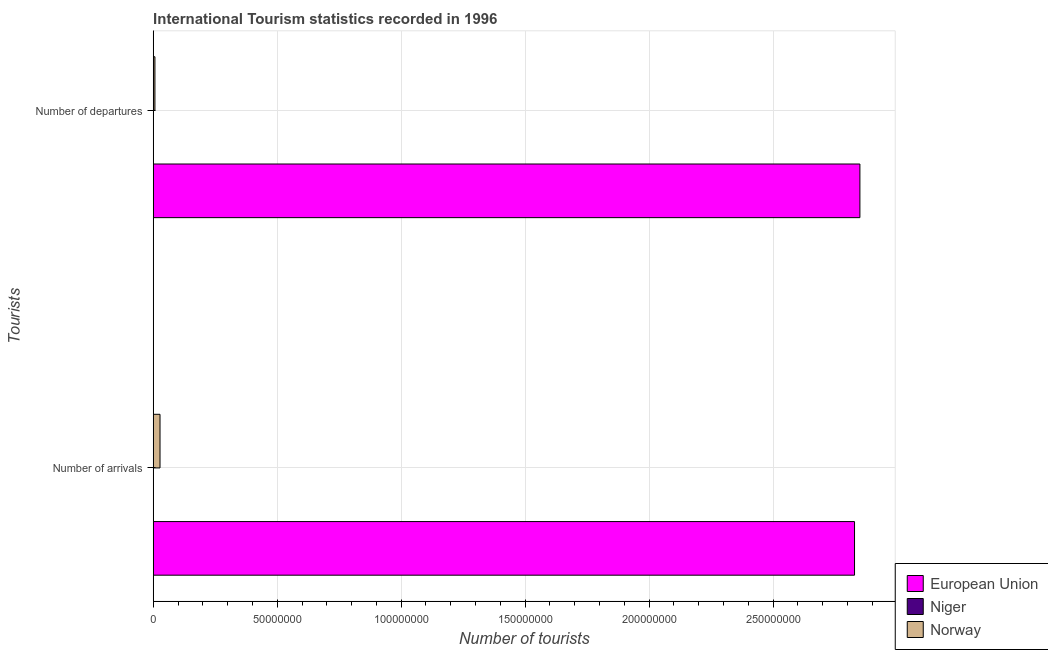How many different coloured bars are there?
Keep it short and to the point. 3. How many groups of bars are there?
Provide a short and direct response. 2. How many bars are there on the 1st tick from the top?
Your response must be concise. 3. What is the label of the 1st group of bars from the top?
Ensure brevity in your answer.  Number of departures. What is the number of tourist arrivals in Niger?
Your answer should be very brief. 6.80e+04. Across all countries, what is the maximum number of tourist departures?
Offer a very short reply. 2.85e+08. Across all countries, what is the minimum number of tourist arrivals?
Keep it short and to the point. 6.80e+04. In which country was the number of tourist arrivals minimum?
Provide a succinct answer. Niger. What is the total number of tourist arrivals in the graph?
Your answer should be compact. 2.86e+08. What is the difference between the number of tourist arrivals in Niger and that in Norway?
Ensure brevity in your answer.  -2.68e+06. What is the difference between the number of tourist departures in Norway and the number of tourist arrivals in Niger?
Your answer should be compact. 6.24e+05. What is the average number of tourist arrivals per country?
Ensure brevity in your answer.  9.52e+07. What is the difference between the number of tourist departures and number of tourist arrivals in Niger?
Your answer should be very brief. -5.80e+04. In how many countries, is the number of tourist arrivals greater than 150000000 ?
Provide a short and direct response. 1. What is the ratio of the number of tourist departures in Niger to that in Norway?
Offer a terse response. 0.01. What does the 1st bar from the top in Number of departures represents?
Give a very brief answer. Norway. What does the 2nd bar from the bottom in Number of arrivals represents?
Provide a succinct answer. Niger. Are all the bars in the graph horizontal?
Ensure brevity in your answer.  Yes. Are the values on the major ticks of X-axis written in scientific E-notation?
Make the answer very short. No. Does the graph contain any zero values?
Offer a very short reply. No. Does the graph contain grids?
Provide a succinct answer. Yes. How many legend labels are there?
Keep it short and to the point. 3. How are the legend labels stacked?
Make the answer very short. Vertical. What is the title of the graph?
Offer a terse response. International Tourism statistics recorded in 1996. Does "Poland" appear as one of the legend labels in the graph?
Your answer should be compact. No. What is the label or title of the X-axis?
Your response must be concise. Number of tourists. What is the label or title of the Y-axis?
Your answer should be very brief. Tourists. What is the Number of tourists in European Union in Number of arrivals?
Your answer should be very brief. 2.83e+08. What is the Number of tourists of Niger in Number of arrivals?
Offer a terse response. 6.80e+04. What is the Number of tourists of Norway in Number of arrivals?
Keep it short and to the point. 2.75e+06. What is the Number of tourists of European Union in Number of departures?
Offer a terse response. 2.85e+08. What is the Number of tourists of Niger in Number of departures?
Provide a short and direct response. 10000. What is the Number of tourists of Norway in Number of departures?
Make the answer very short. 6.92e+05. Across all Tourists, what is the maximum Number of tourists of European Union?
Offer a terse response. 2.85e+08. Across all Tourists, what is the maximum Number of tourists of Niger?
Give a very brief answer. 6.80e+04. Across all Tourists, what is the maximum Number of tourists of Norway?
Offer a very short reply. 2.75e+06. Across all Tourists, what is the minimum Number of tourists of European Union?
Your answer should be very brief. 2.83e+08. Across all Tourists, what is the minimum Number of tourists in Niger?
Offer a very short reply. 10000. Across all Tourists, what is the minimum Number of tourists in Norway?
Offer a terse response. 6.92e+05. What is the total Number of tourists of European Union in the graph?
Keep it short and to the point. 5.68e+08. What is the total Number of tourists of Niger in the graph?
Your response must be concise. 7.80e+04. What is the total Number of tourists in Norway in the graph?
Offer a terse response. 3.44e+06. What is the difference between the Number of tourists in European Union in Number of arrivals and that in Number of departures?
Make the answer very short. -2.17e+06. What is the difference between the Number of tourists of Niger in Number of arrivals and that in Number of departures?
Your answer should be very brief. 5.80e+04. What is the difference between the Number of tourists in Norway in Number of arrivals and that in Number of departures?
Give a very brief answer. 2.05e+06. What is the difference between the Number of tourists of European Union in Number of arrivals and the Number of tourists of Niger in Number of departures?
Provide a succinct answer. 2.83e+08. What is the difference between the Number of tourists in European Union in Number of arrivals and the Number of tourists in Norway in Number of departures?
Your answer should be very brief. 2.82e+08. What is the difference between the Number of tourists of Niger in Number of arrivals and the Number of tourists of Norway in Number of departures?
Make the answer very short. -6.24e+05. What is the average Number of tourists in European Union per Tourists?
Provide a succinct answer. 2.84e+08. What is the average Number of tourists of Niger per Tourists?
Offer a terse response. 3.90e+04. What is the average Number of tourists in Norway per Tourists?
Ensure brevity in your answer.  1.72e+06. What is the difference between the Number of tourists of European Union and Number of tourists of Niger in Number of arrivals?
Your answer should be very brief. 2.83e+08. What is the difference between the Number of tourists in European Union and Number of tourists in Norway in Number of arrivals?
Provide a short and direct response. 2.80e+08. What is the difference between the Number of tourists in Niger and Number of tourists in Norway in Number of arrivals?
Keep it short and to the point. -2.68e+06. What is the difference between the Number of tourists in European Union and Number of tourists in Niger in Number of departures?
Give a very brief answer. 2.85e+08. What is the difference between the Number of tourists of European Union and Number of tourists of Norway in Number of departures?
Offer a very short reply. 2.84e+08. What is the difference between the Number of tourists in Niger and Number of tourists in Norway in Number of departures?
Your response must be concise. -6.82e+05. What is the ratio of the Number of tourists in European Union in Number of arrivals to that in Number of departures?
Offer a very short reply. 0.99. What is the ratio of the Number of tourists in Niger in Number of arrivals to that in Number of departures?
Make the answer very short. 6.8. What is the ratio of the Number of tourists in Norway in Number of arrivals to that in Number of departures?
Your answer should be very brief. 3.97. What is the difference between the highest and the second highest Number of tourists of European Union?
Ensure brevity in your answer.  2.17e+06. What is the difference between the highest and the second highest Number of tourists of Niger?
Offer a terse response. 5.80e+04. What is the difference between the highest and the second highest Number of tourists in Norway?
Your response must be concise. 2.05e+06. What is the difference between the highest and the lowest Number of tourists of European Union?
Offer a very short reply. 2.17e+06. What is the difference between the highest and the lowest Number of tourists in Niger?
Your answer should be very brief. 5.80e+04. What is the difference between the highest and the lowest Number of tourists of Norway?
Offer a very short reply. 2.05e+06. 